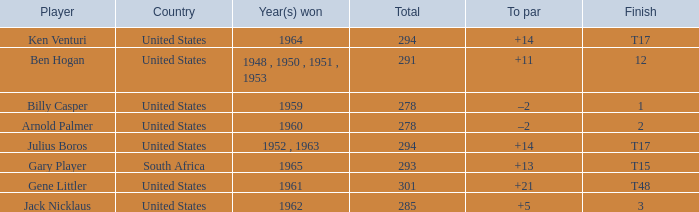What is Year(s) Won, when Total is less than 285? 1959, 1960. 